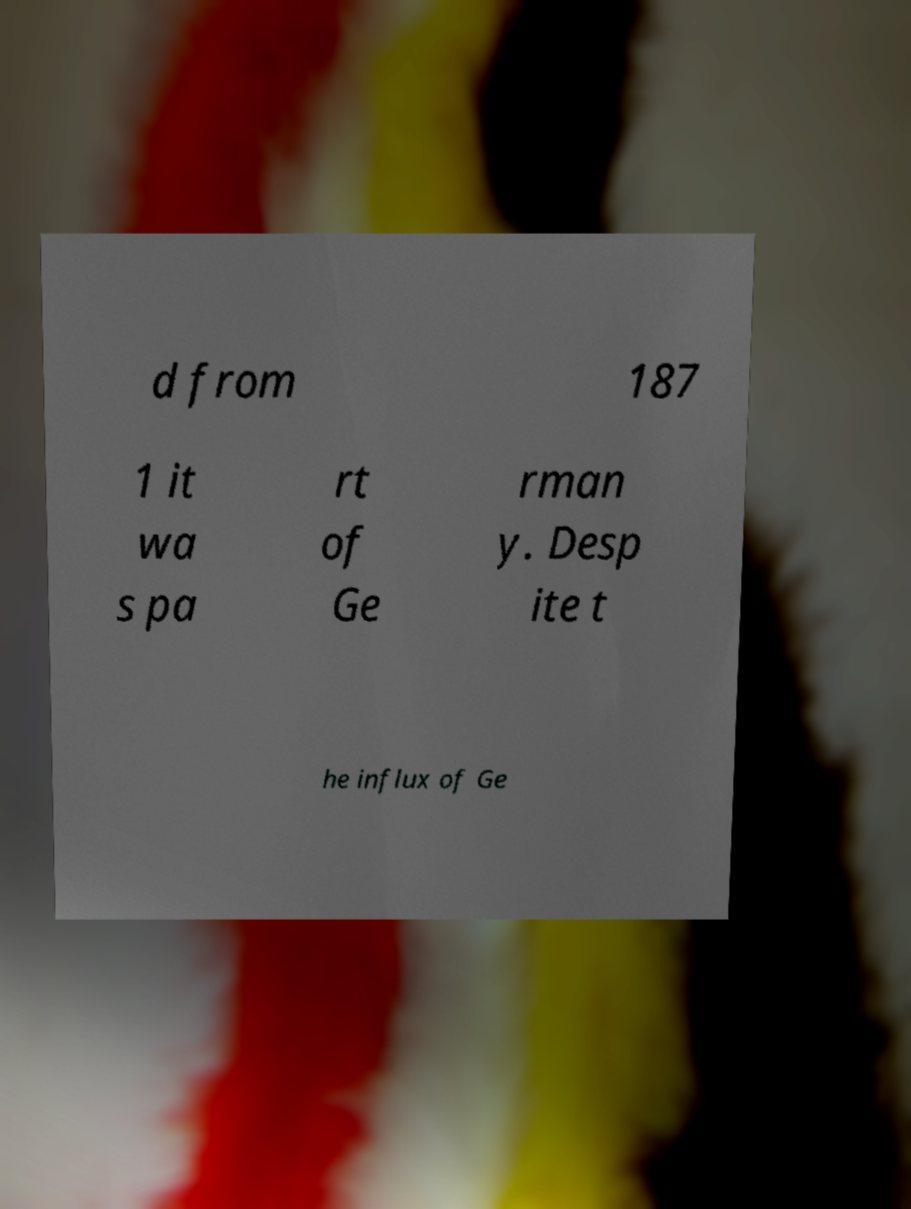I need the written content from this picture converted into text. Can you do that? d from 187 1 it wa s pa rt of Ge rman y. Desp ite t he influx of Ge 